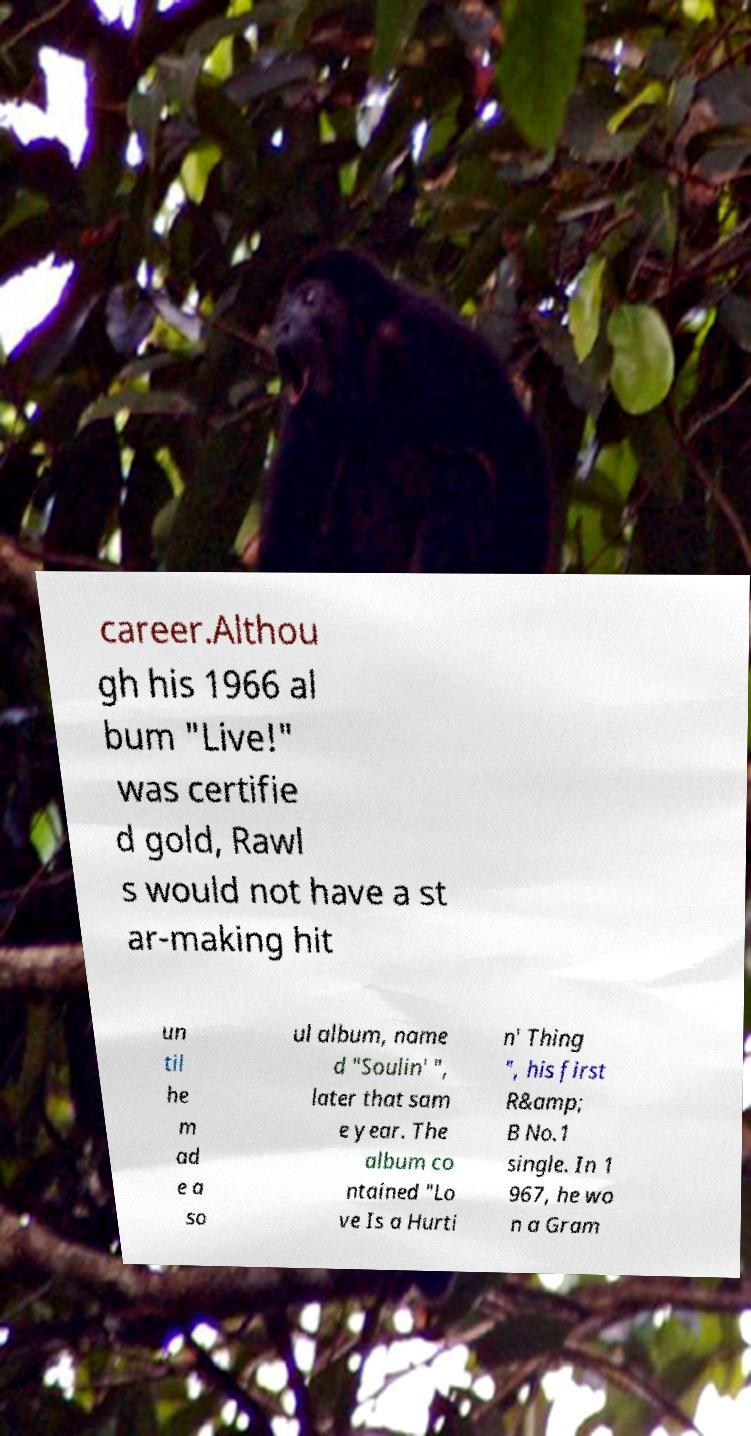Please read and relay the text visible in this image. What does it say? career.Althou gh his 1966 al bum "Live!" was certifie d gold, Rawl s would not have a st ar-making hit un til he m ad e a so ul album, name d "Soulin' ", later that sam e year. The album co ntained "Lo ve Is a Hurti n' Thing ", his first R&amp; B No.1 single. In 1 967, he wo n a Gram 